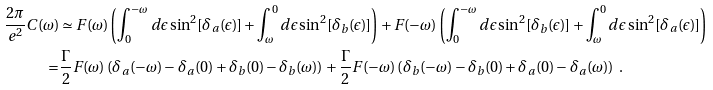<formula> <loc_0><loc_0><loc_500><loc_500>\frac { 2 \pi } { e ^ { 2 } } C ( \omega ) & \simeq F ( \omega ) \left ( \int _ { 0 } ^ { - \omega } d \epsilon \sin ^ { 2 } [ \delta _ { a } ( \epsilon ) ] + \int _ { \omega } ^ { 0 } d \epsilon \sin ^ { 2 } [ \delta _ { b } ( \epsilon ) ] \right ) + F ( - \omega ) \left ( \int _ { 0 } ^ { - \omega } d \epsilon \sin ^ { 2 } [ \delta _ { b } ( \epsilon ) ] + \int _ { \omega } ^ { 0 } d \epsilon \sin ^ { 2 } [ \delta _ { a } ( \epsilon ) ] \right ) \\ = & \frac { \Gamma } { 2 } F ( \omega ) \left ( \delta _ { a } ( - \omega ) - \delta _ { a } ( 0 ) + \delta _ { b } ( 0 ) - \delta _ { b } ( \omega ) \right ) + \frac { \Gamma } { 2 } F ( - \omega ) \left ( \delta _ { b } ( - \omega ) - \delta _ { b } ( 0 ) + \delta _ { a } ( 0 ) - \delta _ { a } ( \omega ) \right ) \ .</formula> 